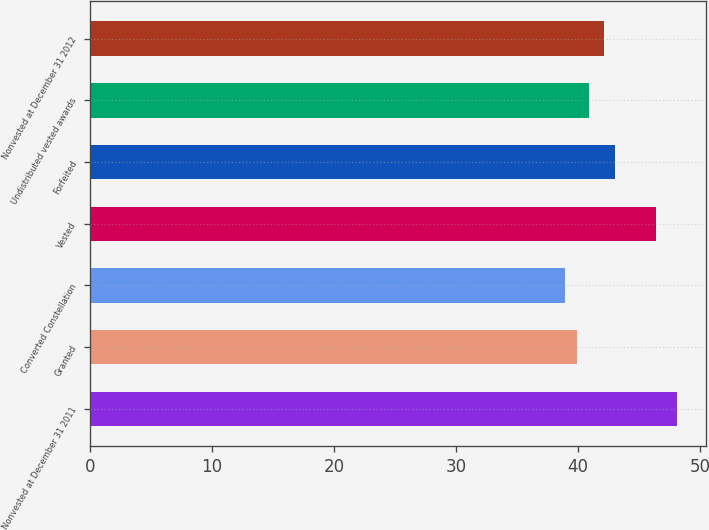Convert chart to OTSL. <chart><loc_0><loc_0><loc_500><loc_500><bar_chart><fcel>Nonvested at December 31 2011<fcel>Granted<fcel>Converted Constellation<fcel>Vested<fcel>Forfeited<fcel>Undistributed vested awards<fcel>Nonvested at December 31 2012<nl><fcel>48.08<fcel>39.94<fcel>38.91<fcel>46.36<fcel>43.04<fcel>40.86<fcel>42.12<nl></chart> 